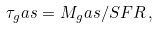<formula> <loc_0><loc_0><loc_500><loc_500>\tau _ { g } a s = M _ { g } a s / S F R \, ,</formula> 